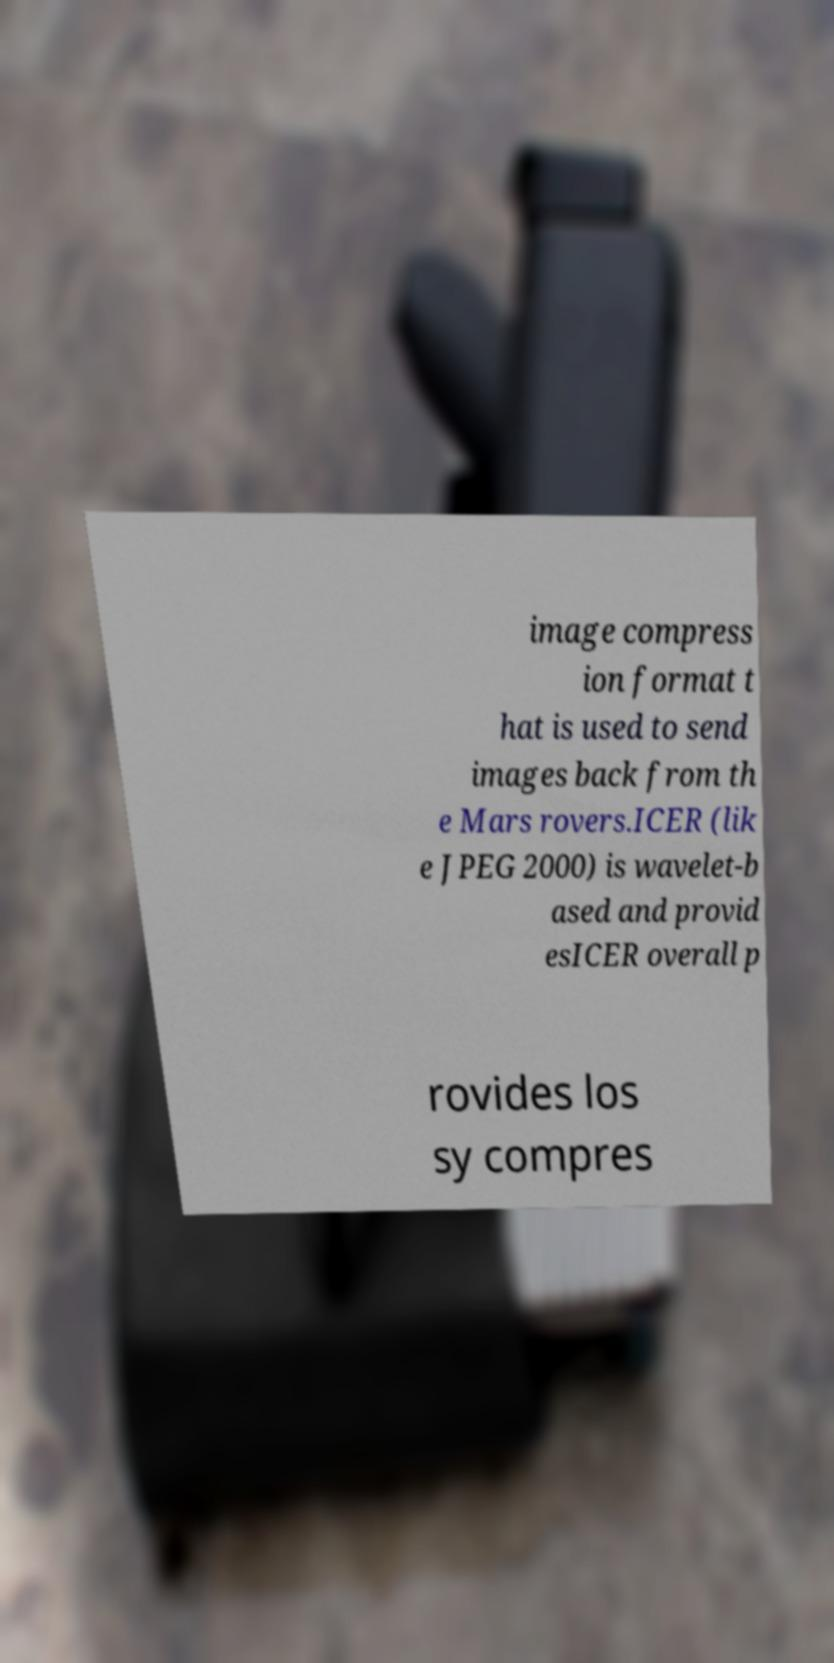Can you accurately transcribe the text from the provided image for me? image compress ion format t hat is used to send images back from th e Mars rovers.ICER (lik e JPEG 2000) is wavelet-b ased and provid esICER overall p rovides los sy compres 